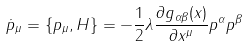Convert formula to latex. <formula><loc_0><loc_0><loc_500><loc_500>\dot { p } _ { \mu } = \{ p _ { \mu } , H \} = - \frac { 1 } { 2 } \lambda \frac { \partial g _ { \alpha \beta } ( x ) } { \partial x ^ { \mu } } p ^ { \alpha } p ^ { \beta }</formula> 